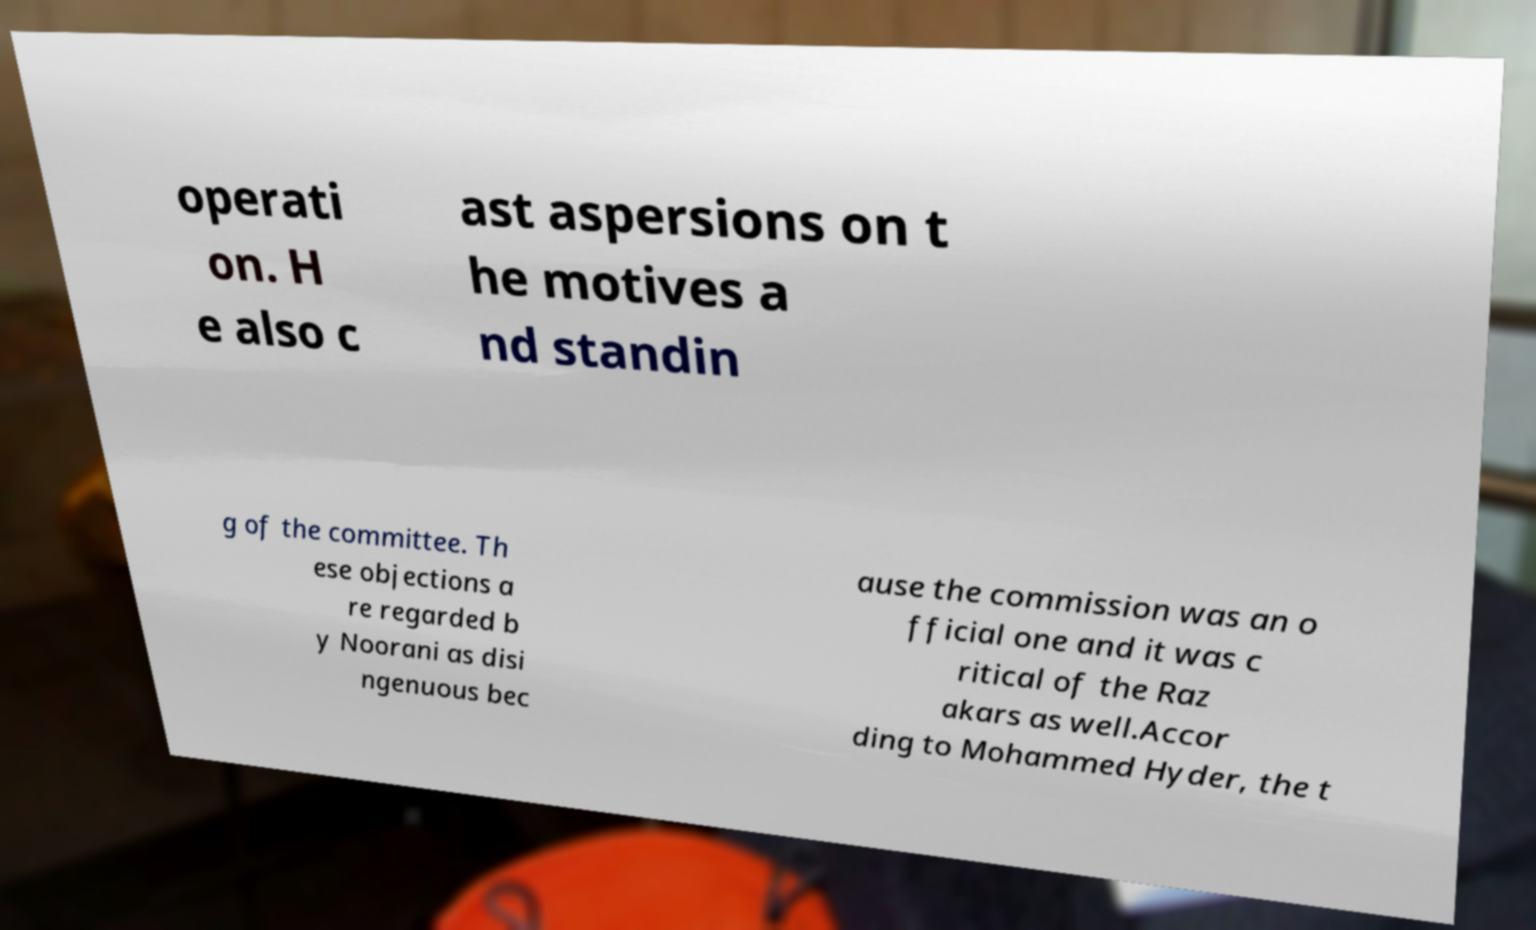For documentation purposes, I need the text within this image transcribed. Could you provide that? operati on. H e also c ast aspersions on t he motives a nd standin g of the committee. Th ese objections a re regarded b y Noorani as disi ngenuous bec ause the commission was an o fficial one and it was c ritical of the Raz akars as well.Accor ding to Mohammed Hyder, the t 